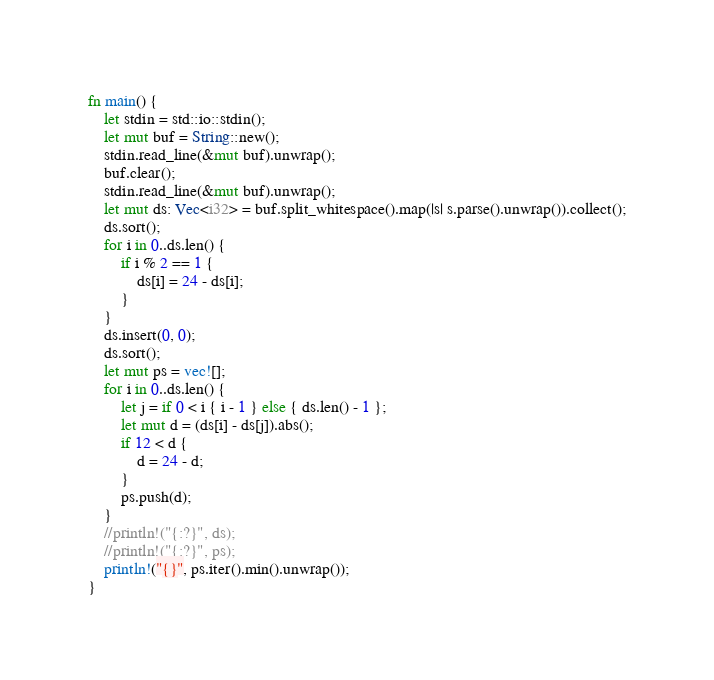Convert code to text. <code><loc_0><loc_0><loc_500><loc_500><_Rust_>fn main() {
    let stdin = std::io::stdin();
    let mut buf = String::new();
    stdin.read_line(&mut buf).unwrap();
    buf.clear();
    stdin.read_line(&mut buf).unwrap();
    let mut ds: Vec<i32> = buf.split_whitespace().map(|s| s.parse().unwrap()).collect();
    ds.sort();
    for i in 0..ds.len() {
        if i % 2 == 1 {
            ds[i] = 24 - ds[i];
        }
    }
    ds.insert(0, 0);
    ds.sort();
    let mut ps = vec![];
    for i in 0..ds.len() {
        let j = if 0 < i { i - 1 } else { ds.len() - 1 };
        let mut d = (ds[i] - ds[j]).abs();
        if 12 < d {
            d = 24 - d;
        }
        ps.push(d);
    }
    //println!("{:?}", ds);
    //println!("{:?}", ps);
    println!("{}", ps.iter().min().unwrap());
}
</code> 